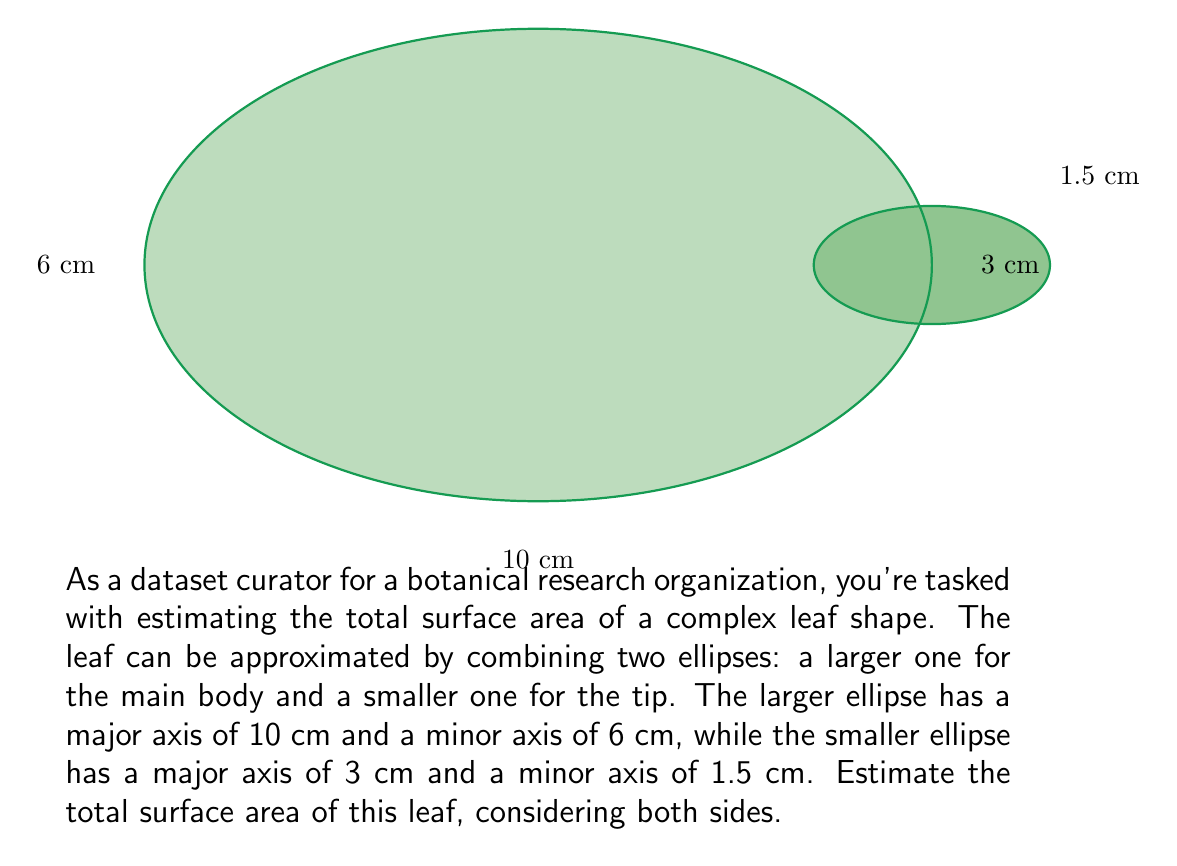Help me with this question. To estimate the surface area of this complex leaf shape, we'll follow these steps:

1) For each ellipse, we'll use the approximation formula for the area of an ellipse:
   $$A \approx \pi ab$$
   where $a$ and $b$ are the semi-major and semi-minor axes, respectively.

2) For the larger ellipse:
   $a_1 = 5$ cm, $b_1 = 3$ cm
   $$A_1 \approx \pi (5)(3) = 15\pi \approx 47.12 \text{ cm}^2$$

3) For the smaller ellipse:
   $a_2 = 1.5$ cm, $b_2 = 0.75$ cm
   $$A_2 \approx \pi (1.5)(0.75) = 1.125\pi \approx 3.53 \text{ cm}^2$$

4) The total area of one side of the leaf is approximately:
   $$A_{total} = A_1 + A_2 \approx 47.12 + 3.53 = 50.65 \text{ cm}^2$$

5) Since we need to consider both sides of the leaf, we multiply this result by 2:
   $$A_{final} \approx 2(50.65) = 101.3 \text{ cm}^2$$

6) Rounding to the nearest whole number:
   $$A_{final} \approx 101 \text{ cm}^2$$
Answer: 101 cm² 